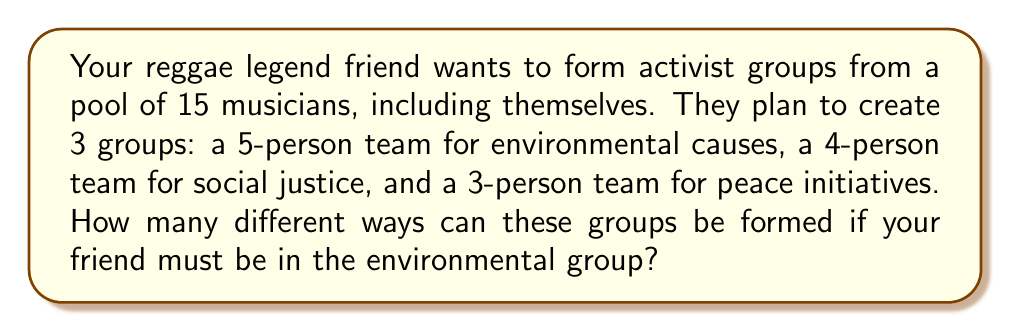Give your solution to this math problem. Let's approach this step-by-step:

1) First, we know that your friend must be in the environmental group, so we only need to select 4 more people for this group from the remaining 14 musicians.

2) We can calculate this using the combination formula:
   $$\binom{14}{4} = \frac{14!}{4!(14-4)!} = \frac{14!}{4!10!} = 1001$$

3) After forming the environmental group, we have 10 musicians left to form the social justice group. We need to choose 4 out of 10:
   $$\binom{10}{4} = \frac{10!}{4!(10-4)!} = \frac{10!}{4!6!} = 210$$

4) Finally, for the peace initiatives group, we need to choose 3 out of the remaining 6 musicians:
   $$\binom{6}{3} = \frac{6!}{3!(6-3)!} = \frac{6!}{3!3!} = 20$$

5) According to the multiplication principle, the total number of ways to form these groups is the product of the individual selections:

   $$1001 \times 210 \times 20 = 4,204,200$$

Therefore, there are 4,204,200 different ways to form these activist groups.
Answer: 4,204,200 